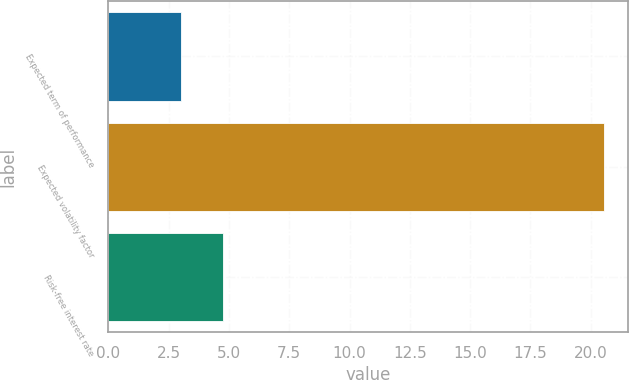Convert chart to OTSL. <chart><loc_0><loc_0><loc_500><loc_500><bar_chart><fcel>Expected term of performance<fcel>Expected volatility factor<fcel>Risk-free interest rate<nl><fcel>3<fcel>20.54<fcel>4.75<nl></chart> 